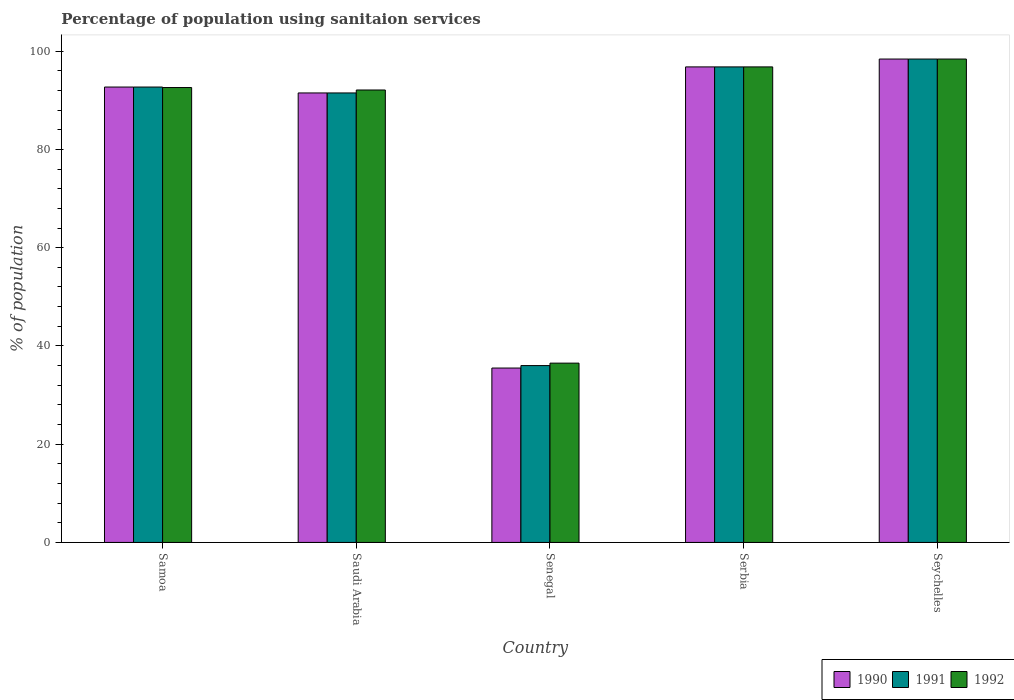How many different coloured bars are there?
Your answer should be compact. 3. How many groups of bars are there?
Your response must be concise. 5. Are the number of bars on each tick of the X-axis equal?
Your answer should be very brief. Yes. How many bars are there on the 3rd tick from the left?
Ensure brevity in your answer.  3. How many bars are there on the 2nd tick from the right?
Offer a terse response. 3. What is the label of the 5th group of bars from the left?
Keep it short and to the point. Seychelles. In how many cases, is the number of bars for a given country not equal to the number of legend labels?
Your answer should be compact. 0. What is the percentage of population using sanitaion services in 1990 in Serbia?
Offer a very short reply. 96.8. Across all countries, what is the maximum percentage of population using sanitaion services in 1992?
Provide a short and direct response. 98.4. Across all countries, what is the minimum percentage of population using sanitaion services in 1991?
Your answer should be very brief. 36. In which country was the percentage of population using sanitaion services in 1991 maximum?
Provide a succinct answer. Seychelles. In which country was the percentage of population using sanitaion services in 1990 minimum?
Make the answer very short. Senegal. What is the total percentage of population using sanitaion services in 1990 in the graph?
Give a very brief answer. 414.9. What is the difference between the percentage of population using sanitaion services in 1990 in Samoa and that in Serbia?
Ensure brevity in your answer.  -4.1. What is the difference between the percentage of population using sanitaion services in 1991 in Seychelles and the percentage of population using sanitaion services in 1992 in Senegal?
Give a very brief answer. 61.9. What is the average percentage of population using sanitaion services in 1992 per country?
Keep it short and to the point. 83.28. What is the ratio of the percentage of population using sanitaion services in 1990 in Samoa to that in Senegal?
Your answer should be compact. 2.61. What is the difference between the highest and the second highest percentage of population using sanitaion services in 1991?
Your response must be concise. -1.6. What is the difference between the highest and the lowest percentage of population using sanitaion services in 1990?
Give a very brief answer. 62.9. Is the sum of the percentage of population using sanitaion services in 1991 in Samoa and Serbia greater than the maximum percentage of population using sanitaion services in 1990 across all countries?
Provide a short and direct response. Yes. What does the 2nd bar from the left in Serbia represents?
Your answer should be compact. 1991. What does the 1st bar from the right in Seychelles represents?
Offer a very short reply. 1992. Are all the bars in the graph horizontal?
Keep it short and to the point. No. How many countries are there in the graph?
Ensure brevity in your answer.  5. Are the values on the major ticks of Y-axis written in scientific E-notation?
Make the answer very short. No. What is the title of the graph?
Your answer should be compact. Percentage of population using sanitaion services. What is the label or title of the Y-axis?
Your response must be concise. % of population. What is the % of population of 1990 in Samoa?
Keep it short and to the point. 92.7. What is the % of population of 1991 in Samoa?
Keep it short and to the point. 92.7. What is the % of population in 1992 in Samoa?
Provide a short and direct response. 92.6. What is the % of population in 1990 in Saudi Arabia?
Offer a terse response. 91.5. What is the % of population in 1991 in Saudi Arabia?
Offer a very short reply. 91.5. What is the % of population of 1992 in Saudi Arabia?
Provide a succinct answer. 92.1. What is the % of population in 1990 in Senegal?
Make the answer very short. 35.5. What is the % of population in 1992 in Senegal?
Your answer should be compact. 36.5. What is the % of population in 1990 in Serbia?
Offer a very short reply. 96.8. What is the % of population of 1991 in Serbia?
Provide a succinct answer. 96.8. What is the % of population in 1992 in Serbia?
Your answer should be very brief. 96.8. What is the % of population in 1990 in Seychelles?
Your answer should be compact. 98.4. What is the % of population of 1991 in Seychelles?
Your answer should be compact. 98.4. What is the % of population in 1992 in Seychelles?
Give a very brief answer. 98.4. Across all countries, what is the maximum % of population in 1990?
Offer a very short reply. 98.4. Across all countries, what is the maximum % of population in 1991?
Your answer should be very brief. 98.4. Across all countries, what is the maximum % of population in 1992?
Provide a succinct answer. 98.4. Across all countries, what is the minimum % of population in 1990?
Keep it short and to the point. 35.5. Across all countries, what is the minimum % of population in 1991?
Your answer should be compact. 36. Across all countries, what is the minimum % of population of 1992?
Offer a terse response. 36.5. What is the total % of population of 1990 in the graph?
Your answer should be compact. 414.9. What is the total % of population in 1991 in the graph?
Your answer should be compact. 415.4. What is the total % of population of 1992 in the graph?
Ensure brevity in your answer.  416.4. What is the difference between the % of population in 1990 in Samoa and that in Saudi Arabia?
Your answer should be compact. 1.2. What is the difference between the % of population in 1990 in Samoa and that in Senegal?
Provide a short and direct response. 57.2. What is the difference between the % of population in 1991 in Samoa and that in Senegal?
Provide a succinct answer. 56.7. What is the difference between the % of population of 1992 in Samoa and that in Senegal?
Keep it short and to the point. 56.1. What is the difference between the % of population of 1990 in Samoa and that in Serbia?
Provide a succinct answer. -4.1. What is the difference between the % of population of 1992 in Samoa and that in Serbia?
Provide a succinct answer. -4.2. What is the difference between the % of population of 1991 in Saudi Arabia and that in Senegal?
Offer a terse response. 55.5. What is the difference between the % of population of 1992 in Saudi Arabia and that in Senegal?
Ensure brevity in your answer.  55.6. What is the difference between the % of population in 1991 in Saudi Arabia and that in Serbia?
Your answer should be very brief. -5.3. What is the difference between the % of population in 1991 in Saudi Arabia and that in Seychelles?
Your answer should be very brief. -6.9. What is the difference between the % of population in 1990 in Senegal and that in Serbia?
Provide a succinct answer. -61.3. What is the difference between the % of population in 1991 in Senegal and that in Serbia?
Keep it short and to the point. -60.8. What is the difference between the % of population in 1992 in Senegal and that in Serbia?
Provide a succinct answer. -60.3. What is the difference between the % of population of 1990 in Senegal and that in Seychelles?
Ensure brevity in your answer.  -62.9. What is the difference between the % of population of 1991 in Senegal and that in Seychelles?
Give a very brief answer. -62.4. What is the difference between the % of population in 1992 in Senegal and that in Seychelles?
Your answer should be compact. -61.9. What is the difference between the % of population of 1990 in Serbia and that in Seychelles?
Your answer should be very brief. -1.6. What is the difference between the % of population of 1992 in Serbia and that in Seychelles?
Ensure brevity in your answer.  -1.6. What is the difference between the % of population of 1991 in Samoa and the % of population of 1992 in Saudi Arabia?
Provide a short and direct response. 0.6. What is the difference between the % of population of 1990 in Samoa and the % of population of 1991 in Senegal?
Offer a terse response. 56.7. What is the difference between the % of population in 1990 in Samoa and the % of population in 1992 in Senegal?
Provide a short and direct response. 56.2. What is the difference between the % of population in 1991 in Samoa and the % of population in 1992 in Senegal?
Keep it short and to the point. 56.2. What is the difference between the % of population of 1990 in Samoa and the % of population of 1991 in Serbia?
Make the answer very short. -4.1. What is the difference between the % of population in 1991 in Samoa and the % of population in 1992 in Serbia?
Make the answer very short. -4.1. What is the difference between the % of population of 1990 in Samoa and the % of population of 1992 in Seychelles?
Your response must be concise. -5.7. What is the difference between the % of population in 1991 in Samoa and the % of population in 1992 in Seychelles?
Provide a short and direct response. -5.7. What is the difference between the % of population in 1990 in Saudi Arabia and the % of population in 1991 in Senegal?
Provide a short and direct response. 55.5. What is the difference between the % of population in 1990 in Saudi Arabia and the % of population in 1992 in Senegal?
Offer a very short reply. 55. What is the difference between the % of population of 1991 in Saudi Arabia and the % of population of 1992 in Senegal?
Your response must be concise. 55. What is the difference between the % of population of 1991 in Saudi Arabia and the % of population of 1992 in Serbia?
Offer a very short reply. -5.3. What is the difference between the % of population in 1990 in Saudi Arabia and the % of population in 1991 in Seychelles?
Your answer should be compact. -6.9. What is the difference between the % of population in 1991 in Saudi Arabia and the % of population in 1992 in Seychelles?
Offer a terse response. -6.9. What is the difference between the % of population in 1990 in Senegal and the % of population in 1991 in Serbia?
Your response must be concise. -61.3. What is the difference between the % of population in 1990 in Senegal and the % of population in 1992 in Serbia?
Ensure brevity in your answer.  -61.3. What is the difference between the % of population in 1991 in Senegal and the % of population in 1992 in Serbia?
Make the answer very short. -60.8. What is the difference between the % of population of 1990 in Senegal and the % of population of 1991 in Seychelles?
Your response must be concise. -62.9. What is the difference between the % of population in 1990 in Senegal and the % of population in 1992 in Seychelles?
Make the answer very short. -62.9. What is the difference between the % of population of 1991 in Senegal and the % of population of 1992 in Seychelles?
Provide a short and direct response. -62.4. What is the difference between the % of population of 1990 in Serbia and the % of population of 1991 in Seychelles?
Make the answer very short. -1.6. What is the difference between the % of population in 1990 in Serbia and the % of population in 1992 in Seychelles?
Offer a terse response. -1.6. What is the difference between the % of population in 1991 in Serbia and the % of population in 1992 in Seychelles?
Make the answer very short. -1.6. What is the average % of population of 1990 per country?
Your response must be concise. 82.98. What is the average % of population of 1991 per country?
Your answer should be very brief. 83.08. What is the average % of population in 1992 per country?
Offer a very short reply. 83.28. What is the difference between the % of population of 1990 and % of population of 1992 in Samoa?
Ensure brevity in your answer.  0.1. What is the difference between the % of population in 1991 and % of population in 1992 in Samoa?
Offer a terse response. 0.1. What is the difference between the % of population of 1991 and % of population of 1992 in Saudi Arabia?
Give a very brief answer. -0.6. What is the difference between the % of population of 1990 and % of population of 1991 in Senegal?
Your response must be concise. -0.5. What is the difference between the % of population in 1991 and % of population in 1992 in Senegal?
Provide a succinct answer. -0.5. What is the difference between the % of population in 1991 and % of population in 1992 in Serbia?
Give a very brief answer. 0. What is the difference between the % of population in 1990 and % of population in 1991 in Seychelles?
Provide a succinct answer. 0. What is the difference between the % of population of 1991 and % of population of 1992 in Seychelles?
Give a very brief answer. 0. What is the ratio of the % of population in 1990 in Samoa to that in Saudi Arabia?
Give a very brief answer. 1.01. What is the ratio of the % of population in 1991 in Samoa to that in Saudi Arabia?
Provide a succinct answer. 1.01. What is the ratio of the % of population of 1992 in Samoa to that in Saudi Arabia?
Offer a terse response. 1.01. What is the ratio of the % of population of 1990 in Samoa to that in Senegal?
Ensure brevity in your answer.  2.61. What is the ratio of the % of population of 1991 in Samoa to that in Senegal?
Your answer should be compact. 2.58. What is the ratio of the % of population in 1992 in Samoa to that in Senegal?
Offer a very short reply. 2.54. What is the ratio of the % of population of 1990 in Samoa to that in Serbia?
Provide a succinct answer. 0.96. What is the ratio of the % of population in 1991 in Samoa to that in Serbia?
Give a very brief answer. 0.96. What is the ratio of the % of population in 1992 in Samoa to that in Serbia?
Offer a terse response. 0.96. What is the ratio of the % of population in 1990 in Samoa to that in Seychelles?
Offer a terse response. 0.94. What is the ratio of the % of population of 1991 in Samoa to that in Seychelles?
Make the answer very short. 0.94. What is the ratio of the % of population in 1992 in Samoa to that in Seychelles?
Your response must be concise. 0.94. What is the ratio of the % of population in 1990 in Saudi Arabia to that in Senegal?
Make the answer very short. 2.58. What is the ratio of the % of population of 1991 in Saudi Arabia to that in Senegal?
Make the answer very short. 2.54. What is the ratio of the % of population of 1992 in Saudi Arabia to that in Senegal?
Offer a very short reply. 2.52. What is the ratio of the % of population in 1990 in Saudi Arabia to that in Serbia?
Offer a very short reply. 0.95. What is the ratio of the % of population of 1991 in Saudi Arabia to that in Serbia?
Provide a succinct answer. 0.95. What is the ratio of the % of population of 1992 in Saudi Arabia to that in Serbia?
Offer a very short reply. 0.95. What is the ratio of the % of population of 1990 in Saudi Arabia to that in Seychelles?
Provide a succinct answer. 0.93. What is the ratio of the % of population of 1991 in Saudi Arabia to that in Seychelles?
Give a very brief answer. 0.93. What is the ratio of the % of population in 1992 in Saudi Arabia to that in Seychelles?
Provide a succinct answer. 0.94. What is the ratio of the % of population in 1990 in Senegal to that in Serbia?
Make the answer very short. 0.37. What is the ratio of the % of population of 1991 in Senegal to that in Serbia?
Your answer should be compact. 0.37. What is the ratio of the % of population in 1992 in Senegal to that in Serbia?
Your answer should be compact. 0.38. What is the ratio of the % of population of 1990 in Senegal to that in Seychelles?
Offer a very short reply. 0.36. What is the ratio of the % of population of 1991 in Senegal to that in Seychelles?
Your answer should be compact. 0.37. What is the ratio of the % of population in 1992 in Senegal to that in Seychelles?
Your answer should be very brief. 0.37. What is the ratio of the % of population in 1990 in Serbia to that in Seychelles?
Provide a short and direct response. 0.98. What is the ratio of the % of population in 1991 in Serbia to that in Seychelles?
Give a very brief answer. 0.98. What is the ratio of the % of population in 1992 in Serbia to that in Seychelles?
Offer a very short reply. 0.98. What is the difference between the highest and the lowest % of population in 1990?
Provide a succinct answer. 62.9. What is the difference between the highest and the lowest % of population in 1991?
Your answer should be compact. 62.4. What is the difference between the highest and the lowest % of population in 1992?
Offer a terse response. 61.9. 